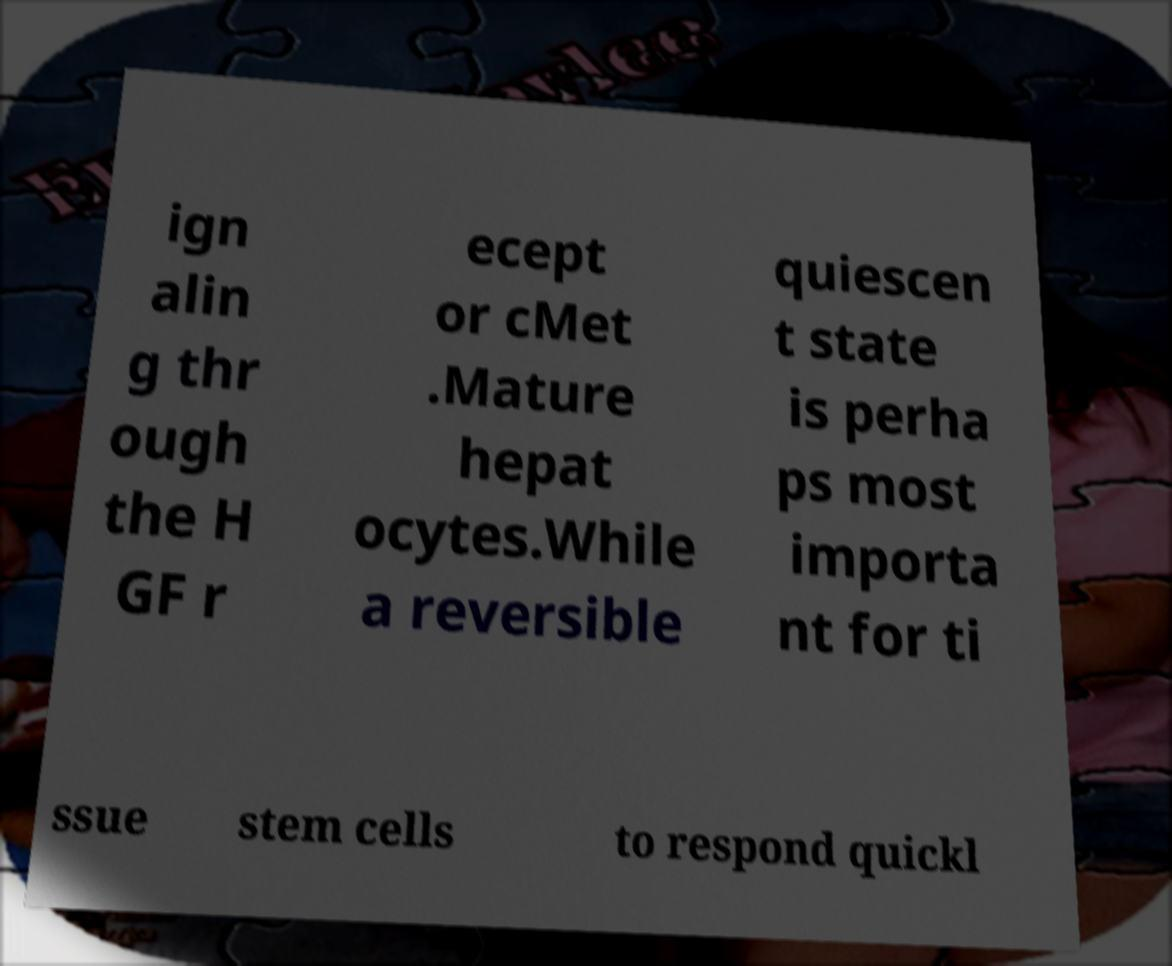There's text embedded in this image that I need extracted. Can you transcribe it verbatim? ign alin g thr ough the H GF r ecept or cMet .Mature hepat ocytes.While a reversible quiescen t state is perha ps most importa nt for ti ssue stem cells to respond quickl 